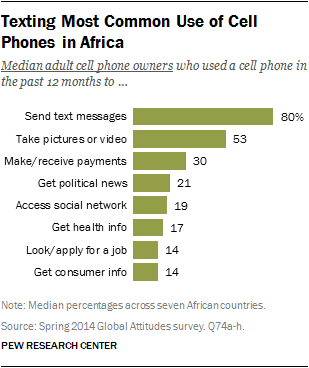Draw attention to some important aspects in this diagram. The sum of the last four uses is not larger than the most common use in the chart. The chart shows 8 uses. 